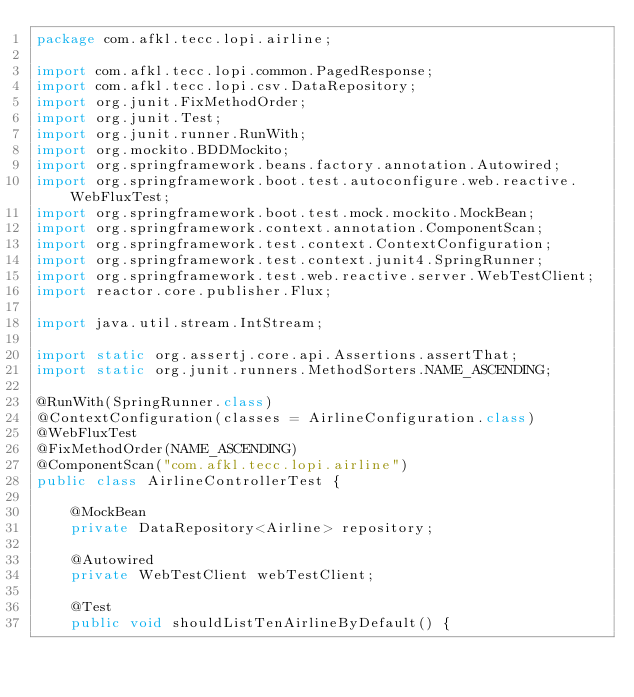<code> <loc_0><loc_0><loc_500><loc_500><_Java_>package com.afkl.tecc.lopi.airline;

import com.afkl.tecc.lopi.common.PagedResponse;
import com.afkl.tecc.lopi.csv.DataRepository;
import org.junit.FixMethodOrder;
import org.junit.Test;
import org.junit.runner.RunWith;
import org.mockito.BDDMockito;
import org.springframework.beans.factory.annotation.Autowired;
import org.springframework.boot.test.autoconfigure.web.reactive.WebFluxTest;
import org.springframework.boot.test.mock.mockito.MockBean;
import org.springframework.context.annotation.ComponentScan;
import org.springframework.test.context.ContextConfiguration;
import org.springframework.test.context.junit4.SpringRunner;
import org.springframework.test.web.reactive.server.WebTestClient;
import reactor.core.publisher.Flux;

import java.util.stream.IntStream;

import static org.assertj.core.api.Assertions.assertThat;
import static org.junit.runners.MethodSorters.NAME_ASCENDING;

@RunWith(SpringRunner.class)
@ContextConfiguration(classes = AirlineConfiguration.class)
@WebFluxTest
@FixMethodOrder(NAME_ASCENDING)
@ComponentScan("com.afkl.tecc.lopi.airline")
public class AirlineControllerTest {

    @MockBean
    private DataRepository<Airline> repository;

    @Autowired
    private WebTestClient webTestClient;

    @Test
    public void shouldListTenAirlineByDefault() {</code> 